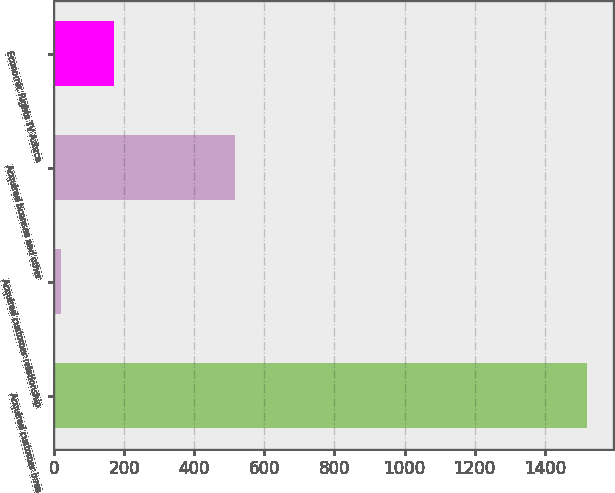Convert chart. <chart><loc_0><loc_0><loc_500><loc_500><bar_chart><fcel>Acquired customer base<fcel>Acquired customer relationship<fcel>Acquired licenses and other<fcel>Economic Rights TV Azteca<nl><fcel>1520<fcel>20<fcel>515<fcel>170<nl></chart> 